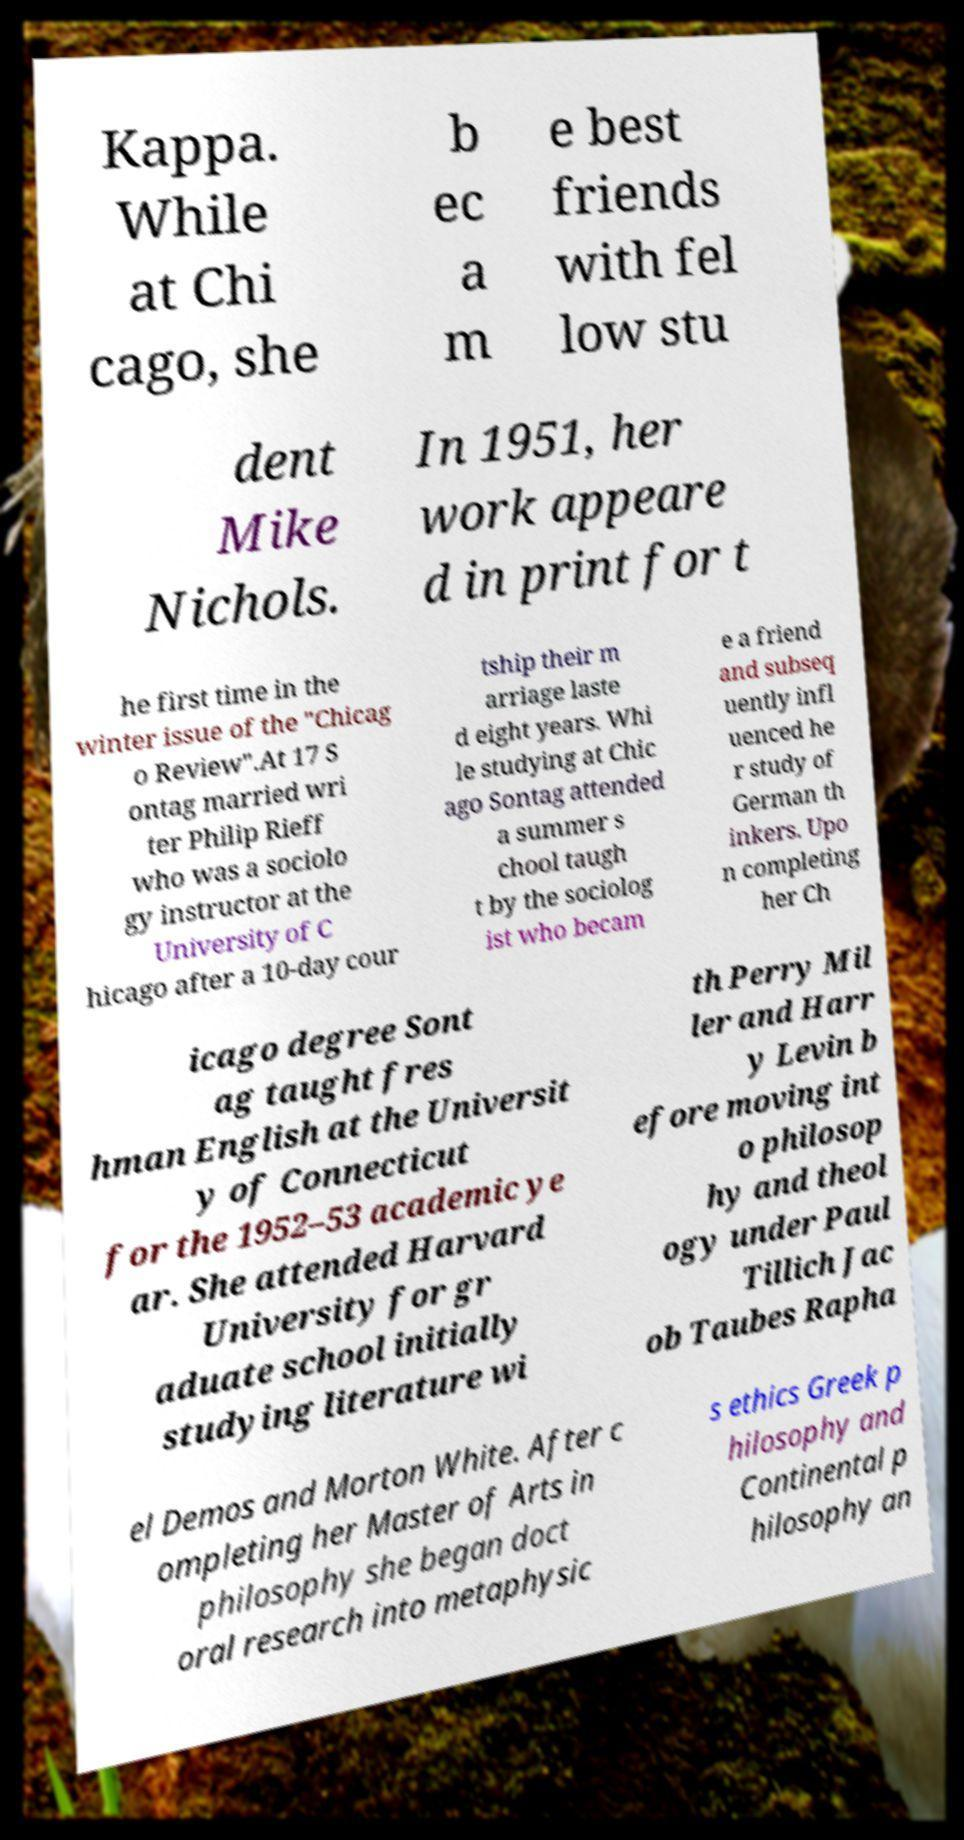Please read and relay the text visible in this image. What does it say? Kappa. While at Chi cago, she b ec a m e best friends with fel low stu dent Mike Nichols. In 1951, her work appeare d in print for t he first time in the winter issue of the "Chicag o Review".At 17 S ontag married wri ter Philip Rieff who was a sociolo gy instructor at the University of C hicago after a 10-day cour tship their m arriage laste d eight years. Whi le studying at Chic ago Sontag attended a summer s chool taugh t by the sociolog ist who becam e a friend and subseq uently infl uenced he r study of German th inkers. Upo n completing her Ch icago degree Sont ag taught fres hman English at the Universit y of Connecticut for the 1952–53 academic ye ar. She attended Harvard University for gr aduate school initially studying literature wi th Perry Mil ler and Harr y Levin b efore moving int o philosop hy and theol ogy under Paul Tillich Jac ob Taubes Rapha el Demos and Morton White. After c ompleting her Master of Arts in philosophy she began doct oral research into metaphysic s ethics Greek p hilosophy and Continental p hilosophy an 